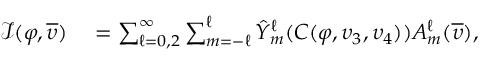<formula> <loc_0><loc_0><loc_500><loc_500>\begin{array} { r l } { \mathcal { I } ( \varphi , \overline { \upsilon } ) } & = \sum _ { \ell = 0 , 2 } ^ { \infty } \sum _ { m = - \ell } ^ { \ell } \hat { Y } _ { m } ^ { \ell } ( C ( \varphi , \upsilon _ { 3 } , \upsilon _ { 4 } ) ) A _ { m } ^ { \ell } ( \overline { \upsilon } ) , } \end{array}</formula> 